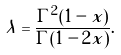<formula> <loc_0><loc_0><loc_500><loc_500>\lambda = \frac { \Gamma ^ { 2 } ( 1 - x ) } { \Gamma ( 1 - 2 x ) } .</formula> 